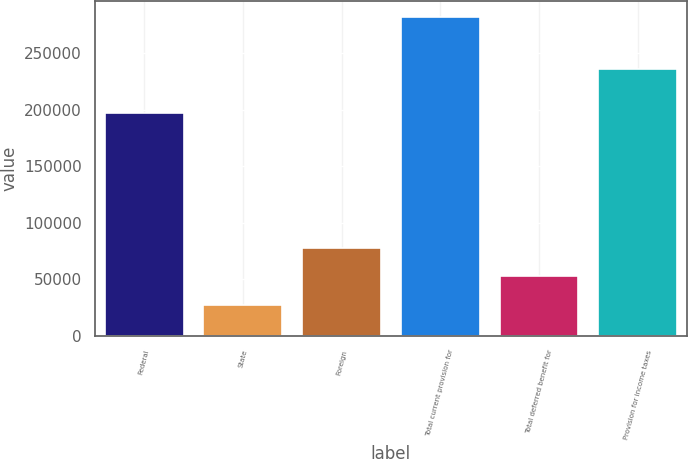<chart> <loc_0><loc_0><loc_500><loc_500><bar_chart><fcel>Federal<fcel>State<fcel>Foreign<fcel>Total current provision for<fcel>Total deferred benefit for<fcel>Provision for income taxes<nl><fcel>196825<fcel>27149<fcel>78138.6<fcel>282097<fcel>52643.8<fcel>235560<nl></chart> 